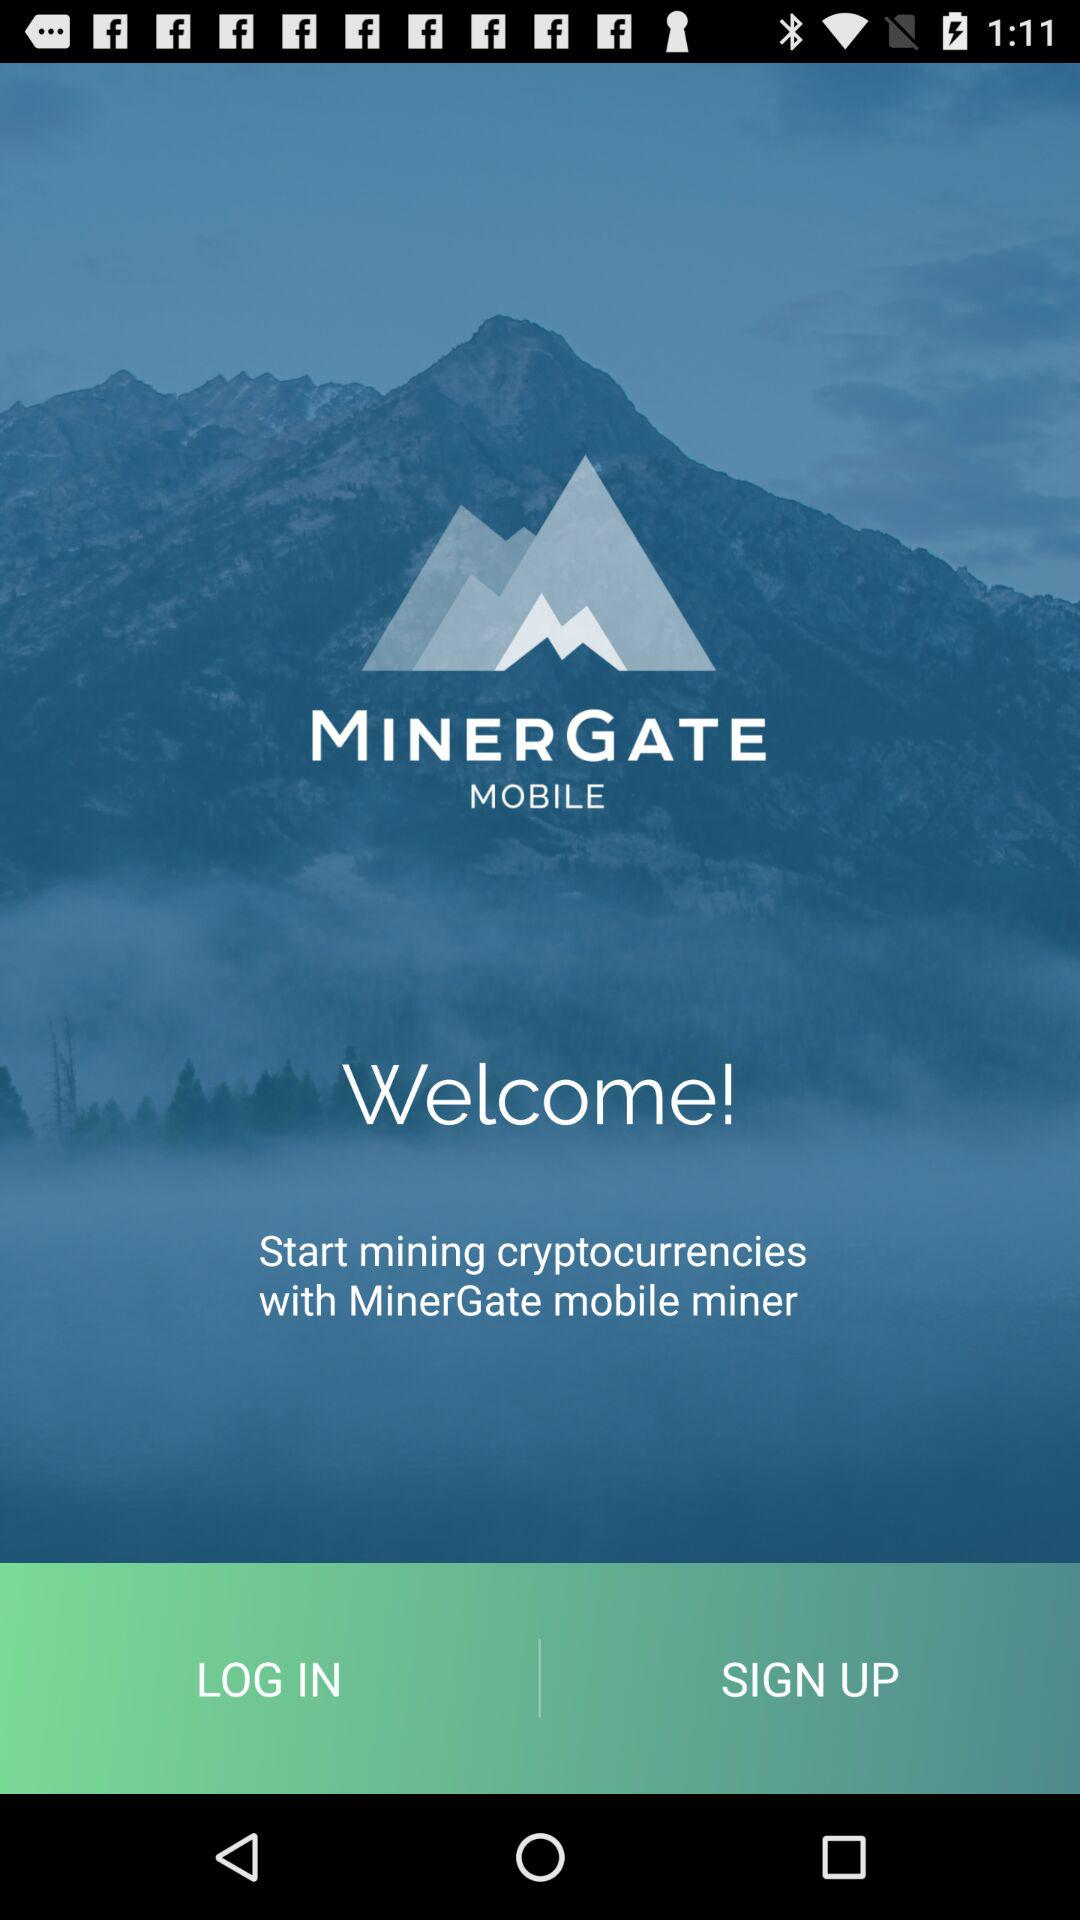What is the application name? The application name is "MINERGATE MOBILE". 